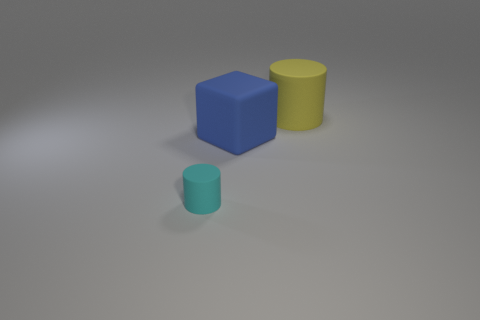Is there anything else that is the same size as the cyan object?
Your answer should be compact. No. What number of small things have the same color as the small rubber cylinder?
Offer a very short reply. 0. There is a small cyan matte thing; what shape is it?
Provide a short and direct response. Cylinder. The matte thing that is both right of the tiny rubber cylinder and in front of the big yellow matte object is what color?
Provide a short and direct response. Blue. What is the yellow cylinder made of?
Your answer should be very brief. Rubber. What shape is the big rubber object that is in front of the yellow rubber object?
Keep it short and to the point. Cube. There is another rubber thing that is the same size as the blue object; what is its color?
Give a very brief answer. Yellow. Are the large thing that is in front of the big rubber cylinder and the big yellow thing made of the same material?
Offer a very short reply. Yes. What is the size of the thing that is behind the cyan rubber cylinder and to the left of the big yellow cylinder?
Your response must be concise. Large. What is the size of the matte cylinder behind the cyan rubber thing?
Make the answer very short. Large. 